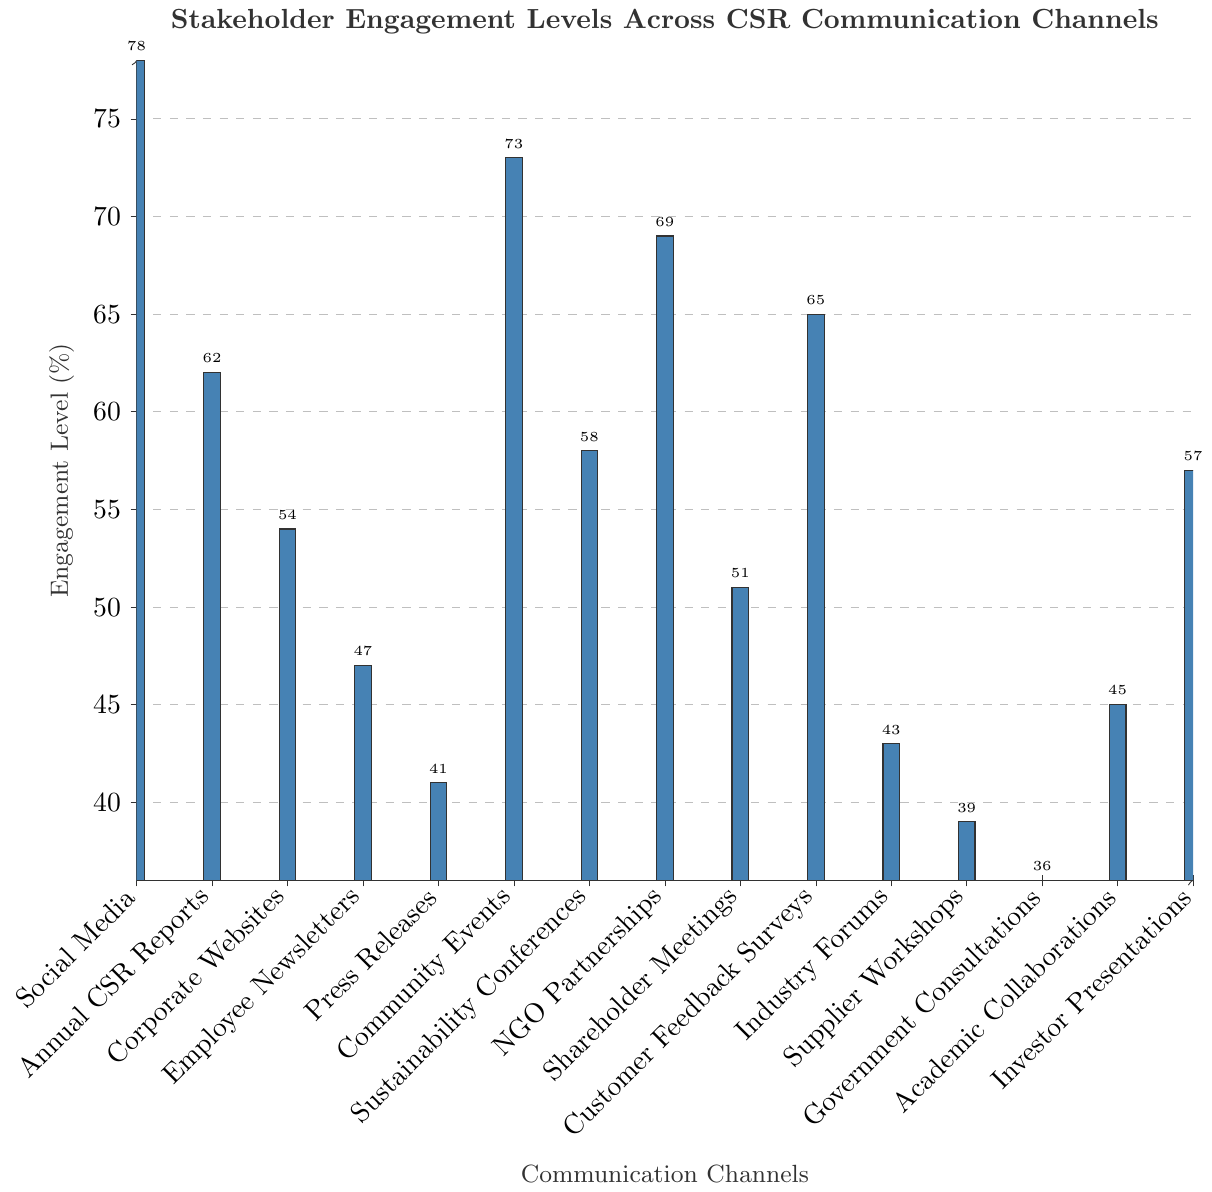Which communication channel has the highest stakeholder engagement level? The highest bar in the chart represents Social Media, indicating it has the highest stakeholder engagement level.
Answer: Social Media What is the difference in engagement level between Social Media and Government Consultations? The engagement level for Social Media is 78% and for Government Consultations is 36%. The difference is calculated as 78 - 36.
Answer: 42 Which communication channel has a higher engagement level, NGO Partnerships or Customer Feedback Surveys? The engagement level for NGO Partnerships is 69% and for Customer Feedback Surveys is 65%. Comparing these two, NGO Partnerships has a higher engagement level.
Answer: NGO Partnerships What is the average engagement level of all the channels listed in the figure? Sum all engagement levels: 78 + 62 + 54 + 47 + 41 + 73 + 58 + 69 + 51 + 65 + 43 + 39 + 36 + 45 + 57 = 818. There are 15 channels, so the average is 818 / 15.
Answer: 54.53 Between Community Events and Sustainability Conferences, which one has a lower engagement level and by how much? Community Events' engagement level is 73% and Sustainability Conferences' is 58%. The difference is 73 - 58.
Answer: Sustainability Conferences, 15 Which communication channels have engagement levels above 60%? The bars above 60% represent Social Media, Annual CSR Reports, Community Events, NGO Partnerships, and Customer Feedback Surveys.
Answer: Social Media, Annual CSR Reports, Community Events, NGO Partnerships, Customer Feedback Surveys What is the median engagement level among the communication channels? Arrange the engagement levels in ascending order: 36, 39, 41, 43, 45, 47, 51, 54, 57, 58, 62, 65, 69, 73, 78. The median level is the 8th value in this list.
Answer: 54 How much higher is the engagement level for Social Media compared to the average engagement level of all channels? Average engagement level is 54.53%. Social Media's engagement level is 78%. The difference is 78 - 54.53.
Answer: 23.47 Which channels have engagement levels between 40% and 60%? The bars that fall within this range represent Corporate Websites, Employee Newsletters, Press Releases, Sustainability Conferences, Shareholder Meetings, Industry Forums, Academic Collaborations, and Investor Presentations.
Answer: Corporate Websites, Employee Newsletters, Press Releases, Sustainability Conferences, Shareholder Meetings, Industry Forums, Academic Collaborations, Investor Presentations 